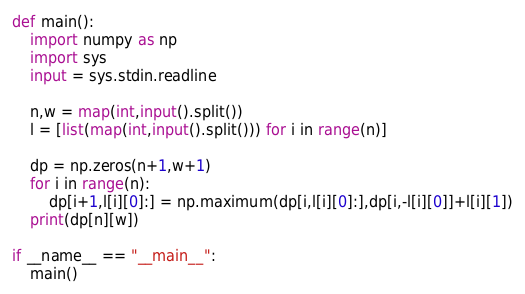<code> <loc_0><loc_0><loc_500><loc_500><_Python_>def main():
    import numpy as np
    import sys
    input = sys.stdin.readline

    n,w = map(int,input().split())
    l = [list(map(int,input().split())) for i in range(n)]

    dp = np.zeros(n+1,w+1)
    for i in range(n):
        dp[i+1,l[i][0]:] = np.maximum(dp[i,l[i][0]:],dp[i,-l[i][0]]+l[i][1])
    print(dp[n][w])

if __name__ == "__main__":
    main()</code> 